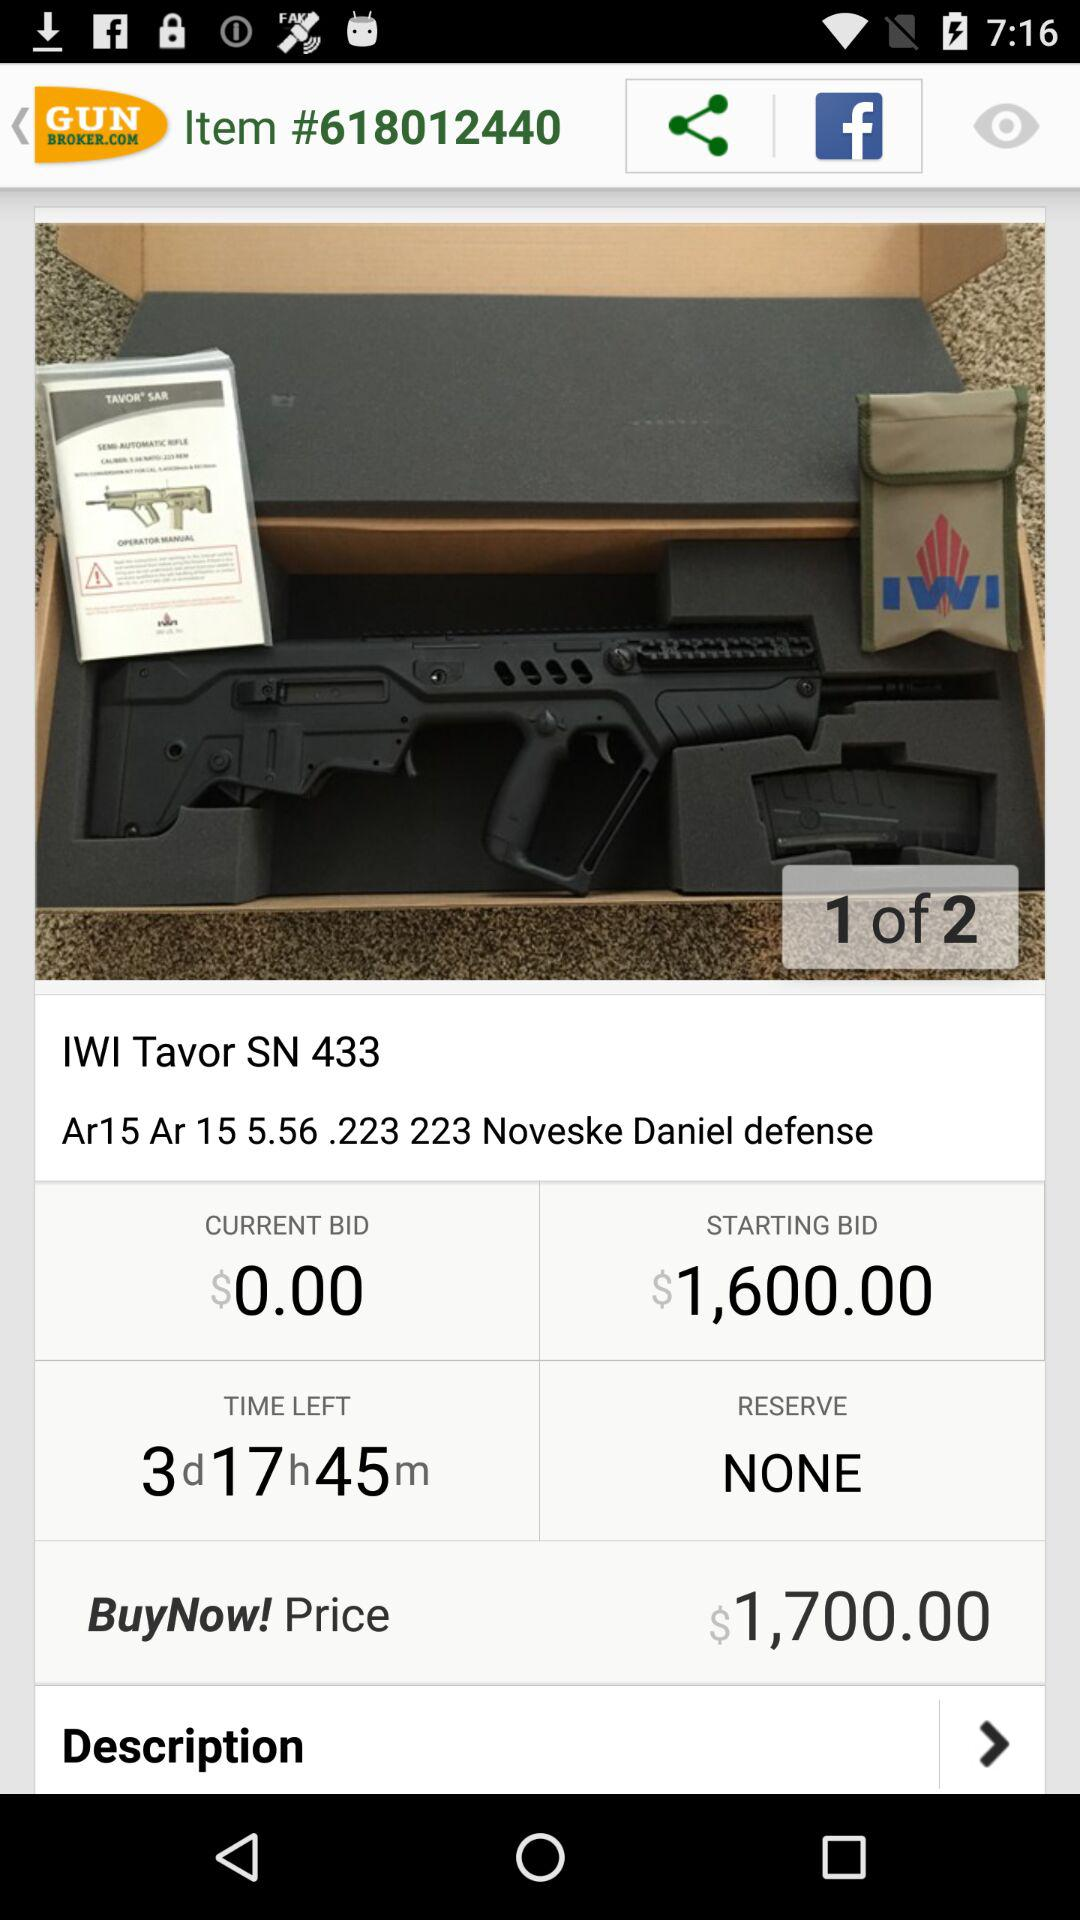How much time is left? There are 3 days 17 hours 45 minutes left. 